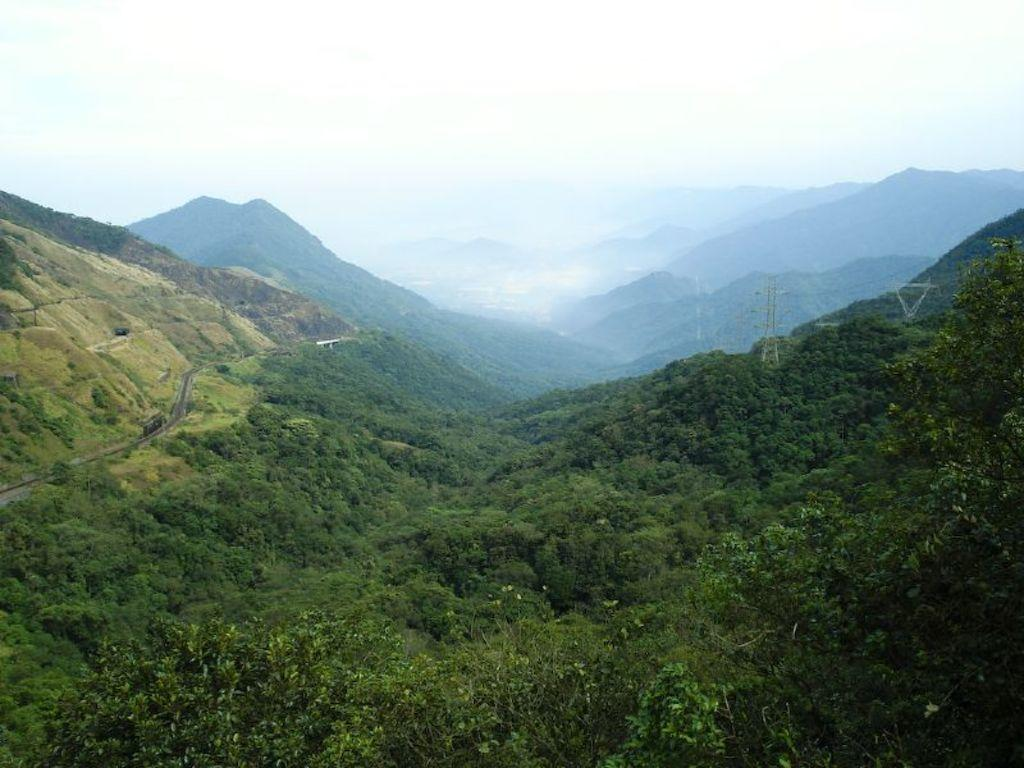What type of vegetation is present in the image? There are trees in the image. What is the color of the trees? The trees are green. What can be seen in the distance behind the trees? There are mountains in the background of the image. What is the color of the sky in the image? The sky is white in color. How many books are stacked on the lizards in the image? There are no books or lizards present in the image; it features trees, mountains, and a white sky. 